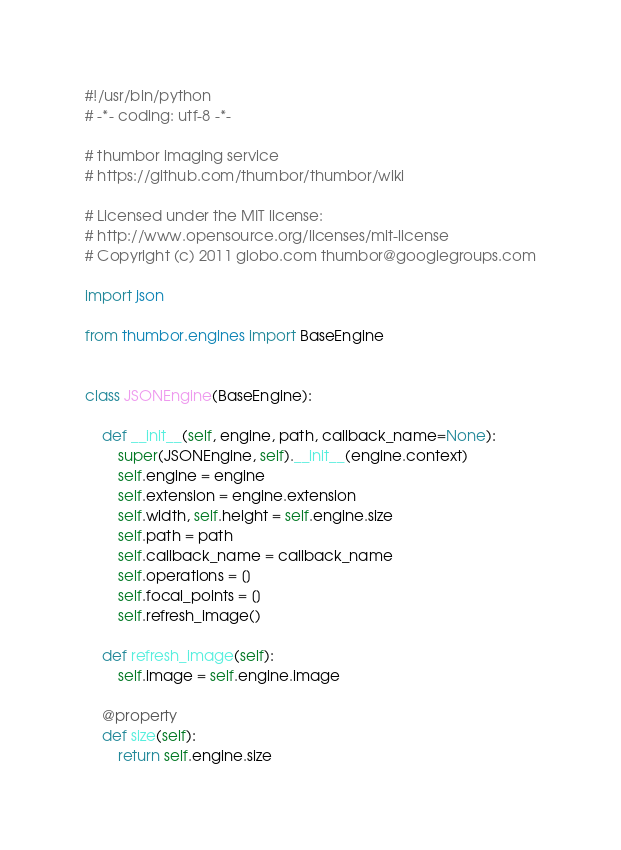Convert code to text. <code><loc_0><loc_0><loc_500><loc_500><_Python_>#!/usr/bin/python
# -*- coding: utf-8 -*-

# thumbor imaging service
# https://github.com/thumbor/thumbor/wiki

# Licensed under the MIT license:
# http://www.opensource.org/licenses/mit-license
# Copyright (c) 2011 globo.com thumbor@googlegroups.com

import json

from thumbor.engines import BaseEngine


class JSONEngine(BaseEngine):

    def __init__(self, engine, path, callback_name=None):
        super(JSONEngine, self).__init__(engine.context)
        self.engine = engine
        self.extension = engine.extension
        self.width, self.height = self.engine.size
        self.path = path
        self.callback_name = callback_name
        self.operations = []
        self.focal_points = []
        self.refresh_image()

    def refresh_image(self):
        self.image = self.engine.image

    @property
    def size(self):
        return self.engine.size
</code> 